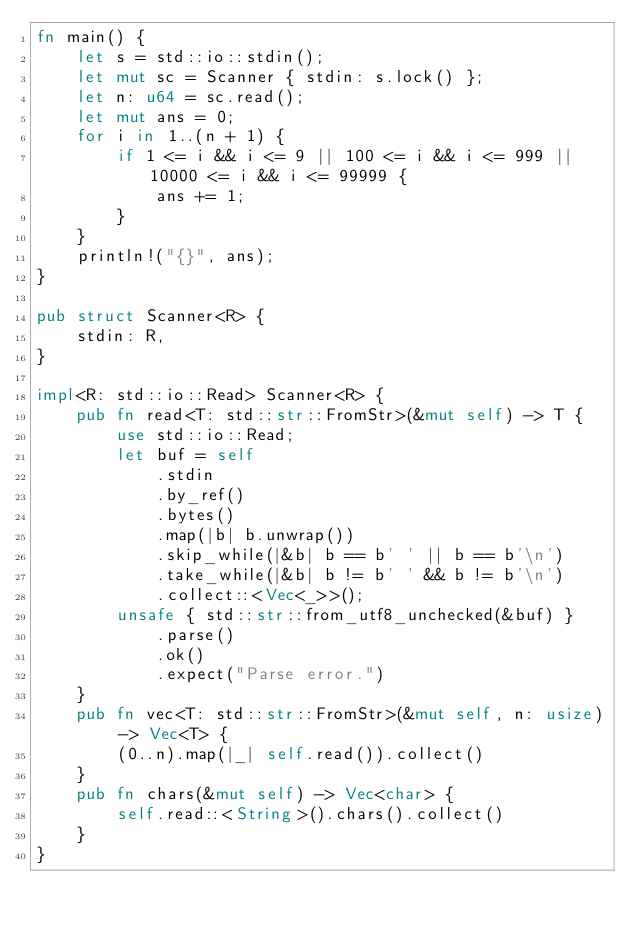Convert code to text. <code><loc_0><loc_0><loc_500><loc_500><_Rust_>fn main() {
    let s = std::io::stdin();
    let mut sc = Scanner { stdin: s.lock() };
    let n: u64 = sc.read();
    let mut ans = 0;
    for i in 1..(n + 1) {
        if 1 <= i && i <= 9 || 100 <= i && i <= 999 || 10000 <= i && i <= 99999 {
            ans += 1;
        }
    }
    println!("{}", ans);
}

pub struct Scanner<R> {
    stdin: R,
}

impl<R: std::io::Read> Scanner<R> {
    pub fn read<T: std::str::FromStr>(&mut self) -> T {
        use std::io::Read;
        let buf = self
            .stdin
            .by_ref()
            .bytes()
            .map(|b| b.unwrap())
            .skip_while(|&b| b == b' ' || b == b'\n')
            .take_while(|&b| b != b' ' && b != b'\n')
            .collect::<Vec<_>>();
        unsafe { std::str::from_utf8_unchecked(&buf) }
            .parse()
            .ok()
            .expect("Parse error.")
    }
    pub fn vec<T: std::str::FromStr>(&mut self, n: usize) -> Vec<T> {
        (0..n).map(|_| self.read()).collect()
    }
    pub fn chars(&mut self) -> Vec<char> {
        self.read::<String>().chars().collect()
    }
}
</code> 